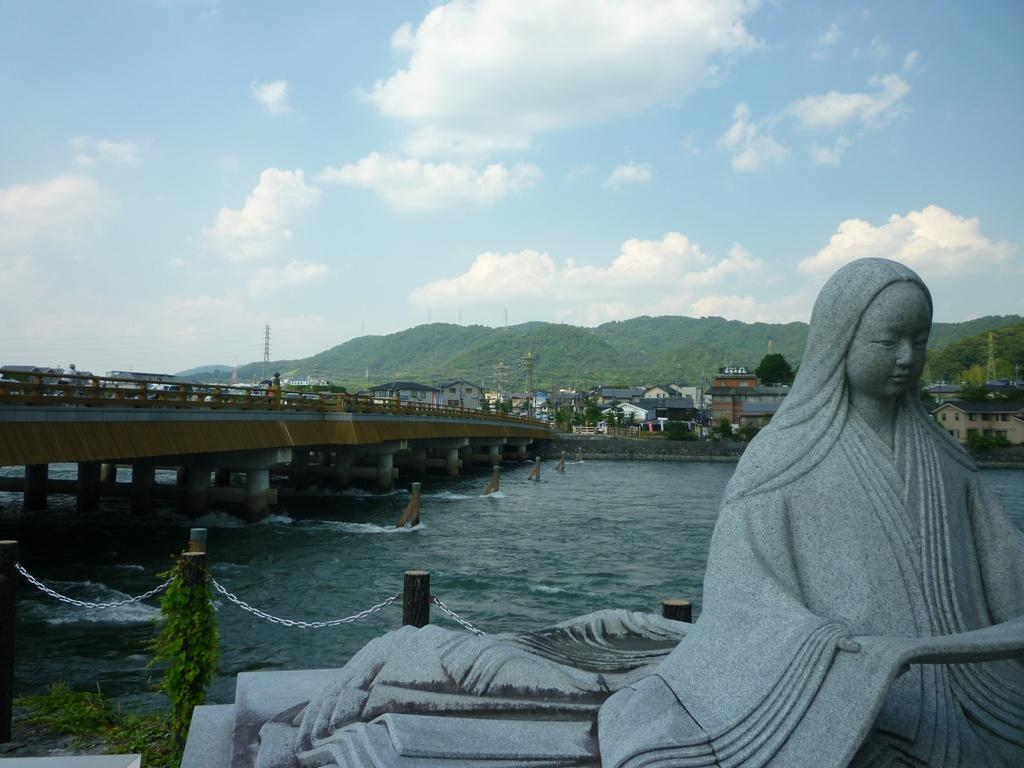What is the main subject in the foreground of the image? There is a sculpture in the foreground of the image. What can be seen in the middle of the image? There is a lake, a bridge, and houses in the middle of the image. What is located at the top of the image? There is a hill at the top of the image. What is visible in the background of the image? The sky is visible in the image. What type of ring can be seen on the sculpture's finger in the image? There is no ring visible on the sculpture's finger in the image. What is the purpose of the sculpture in the image? The facts provided do not give any information about the purpose of the sculpture. 